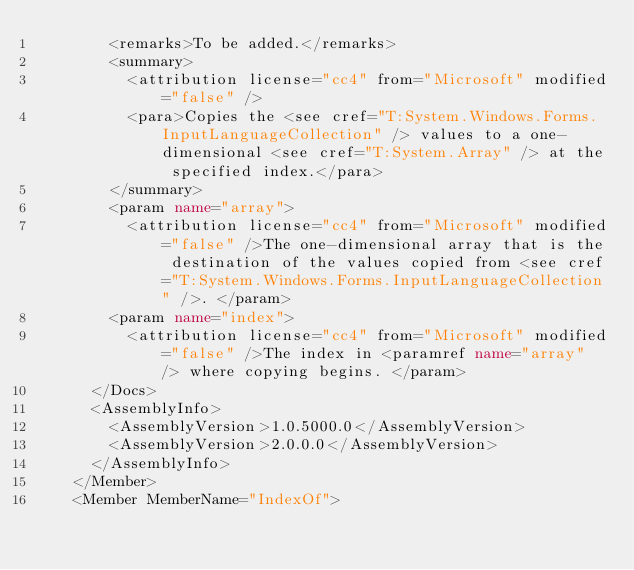<code> <loc_0><loc_0><loc_500><loc_500><_XML_>        <remarks>To be added.</remarks>
        <summary>
          <attribution license="cc4" from="Microsoft" modified="false" />
          <para>Copies the <see cref="T:System.Windows.Forms.InputLanguageCollection" /> values to a one-dimensional <see cref="T:System.Array" /> at the specified index.</para>
        </summary>
        <param name="array">
          <attribution license="cc4" from="Microsoft" modified="false" />The one-dimensional array that is the destination of the values copied from <see cref="T:System.Windows.Forms.InputLanguageCollection" />. </param>
        <param name="index">
          <attribution license="cc4" from="Microsoft" modified="false" />The index in <paramref name="array" /> where copying begins. </param>
      </Docs>
      <AssemblyInfo>
        <AssemblyVersion>1.0.5000.0</AssemblyVersion>
        <AssemblyVersion>2.0.0.0</AssemblyVersion>
      </AssemblyInfo>
    </Member>
    <Member MemberName="IndexOf"></code> 